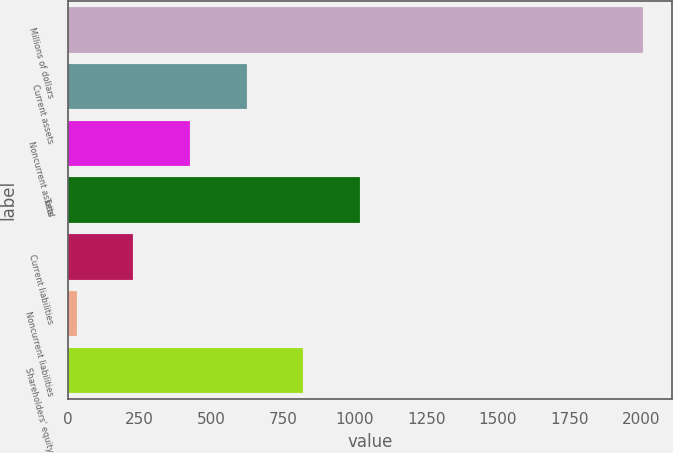Convert chart. <chart><loc_0><loc_0><loc_500><loc_500><bar_chart><fcel>Millions of dollars<fcel>Current assets<fcel>Noncurrent assets<fcel>Total<fcel>Current liabilities<fcel>Noncurrent liabilities<fcel>Shareholders' equity<nl><fcel>2006<fcel>623.5<fcel>426<fcel>1018.5<fcel>228.5<fcel>31<fcel>821<nl></chart> 